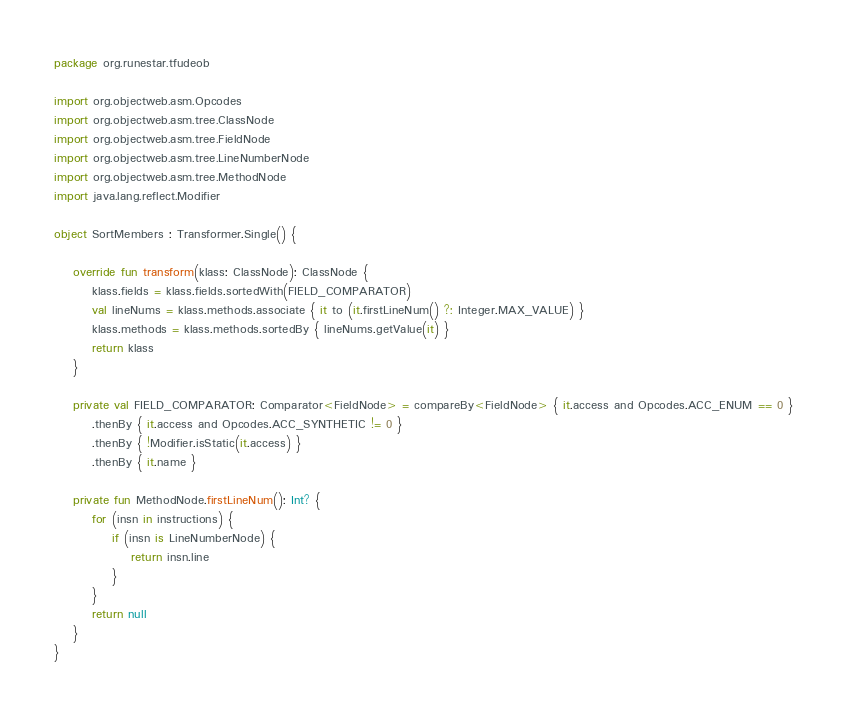<code> <loc_0><loc_0><loc_500><loc_500><_Kotlin_>package org.runestar.tfudeob

import org.objectweb.asm.Opcodes
import org.objectweb.asm.tree.ClassNode
import org.objectweb.asm.tree.FieldNode
import org.objectweb.asm.tree.LineNumberNode
import org.objectweb.asm.tree.MethodNode
import java.lang.reflect.Modifier

object SortMembers : Transformer.Single() {

    override fun transform(klass: ClassNode): ClassNode {
        klass.fields = klass.fields.sortedWith(FIELD_COMPARATOR)
        val lineNums = klass.methods.associate { it to (it.firstLineNum() ?: Integer.MAX_VALUE) }
        klass.methods = klass.methods.sortedBy { lineNums.getValue(it) }
        return klass
    }

    private val FIELD_COMPARATOR: Comparator<FieldNode> = compareBy<FieldNode> { it.access and Opcodes.ACC_ENUM == 0 }
        .thenBy { it.access and Opcodes.ACC_SYNTHETIC != 0 }
        .thenBy { !Modifier.isStatic(it.access) }
        .thenBy { it.name }

    private fun MethodNode.firstLineNum(): Int? {
        for (insn in instructions) {
            if (insn is LineNumberNode) {
                return insn.line
            }
        }
        return null
    }
}</code> 